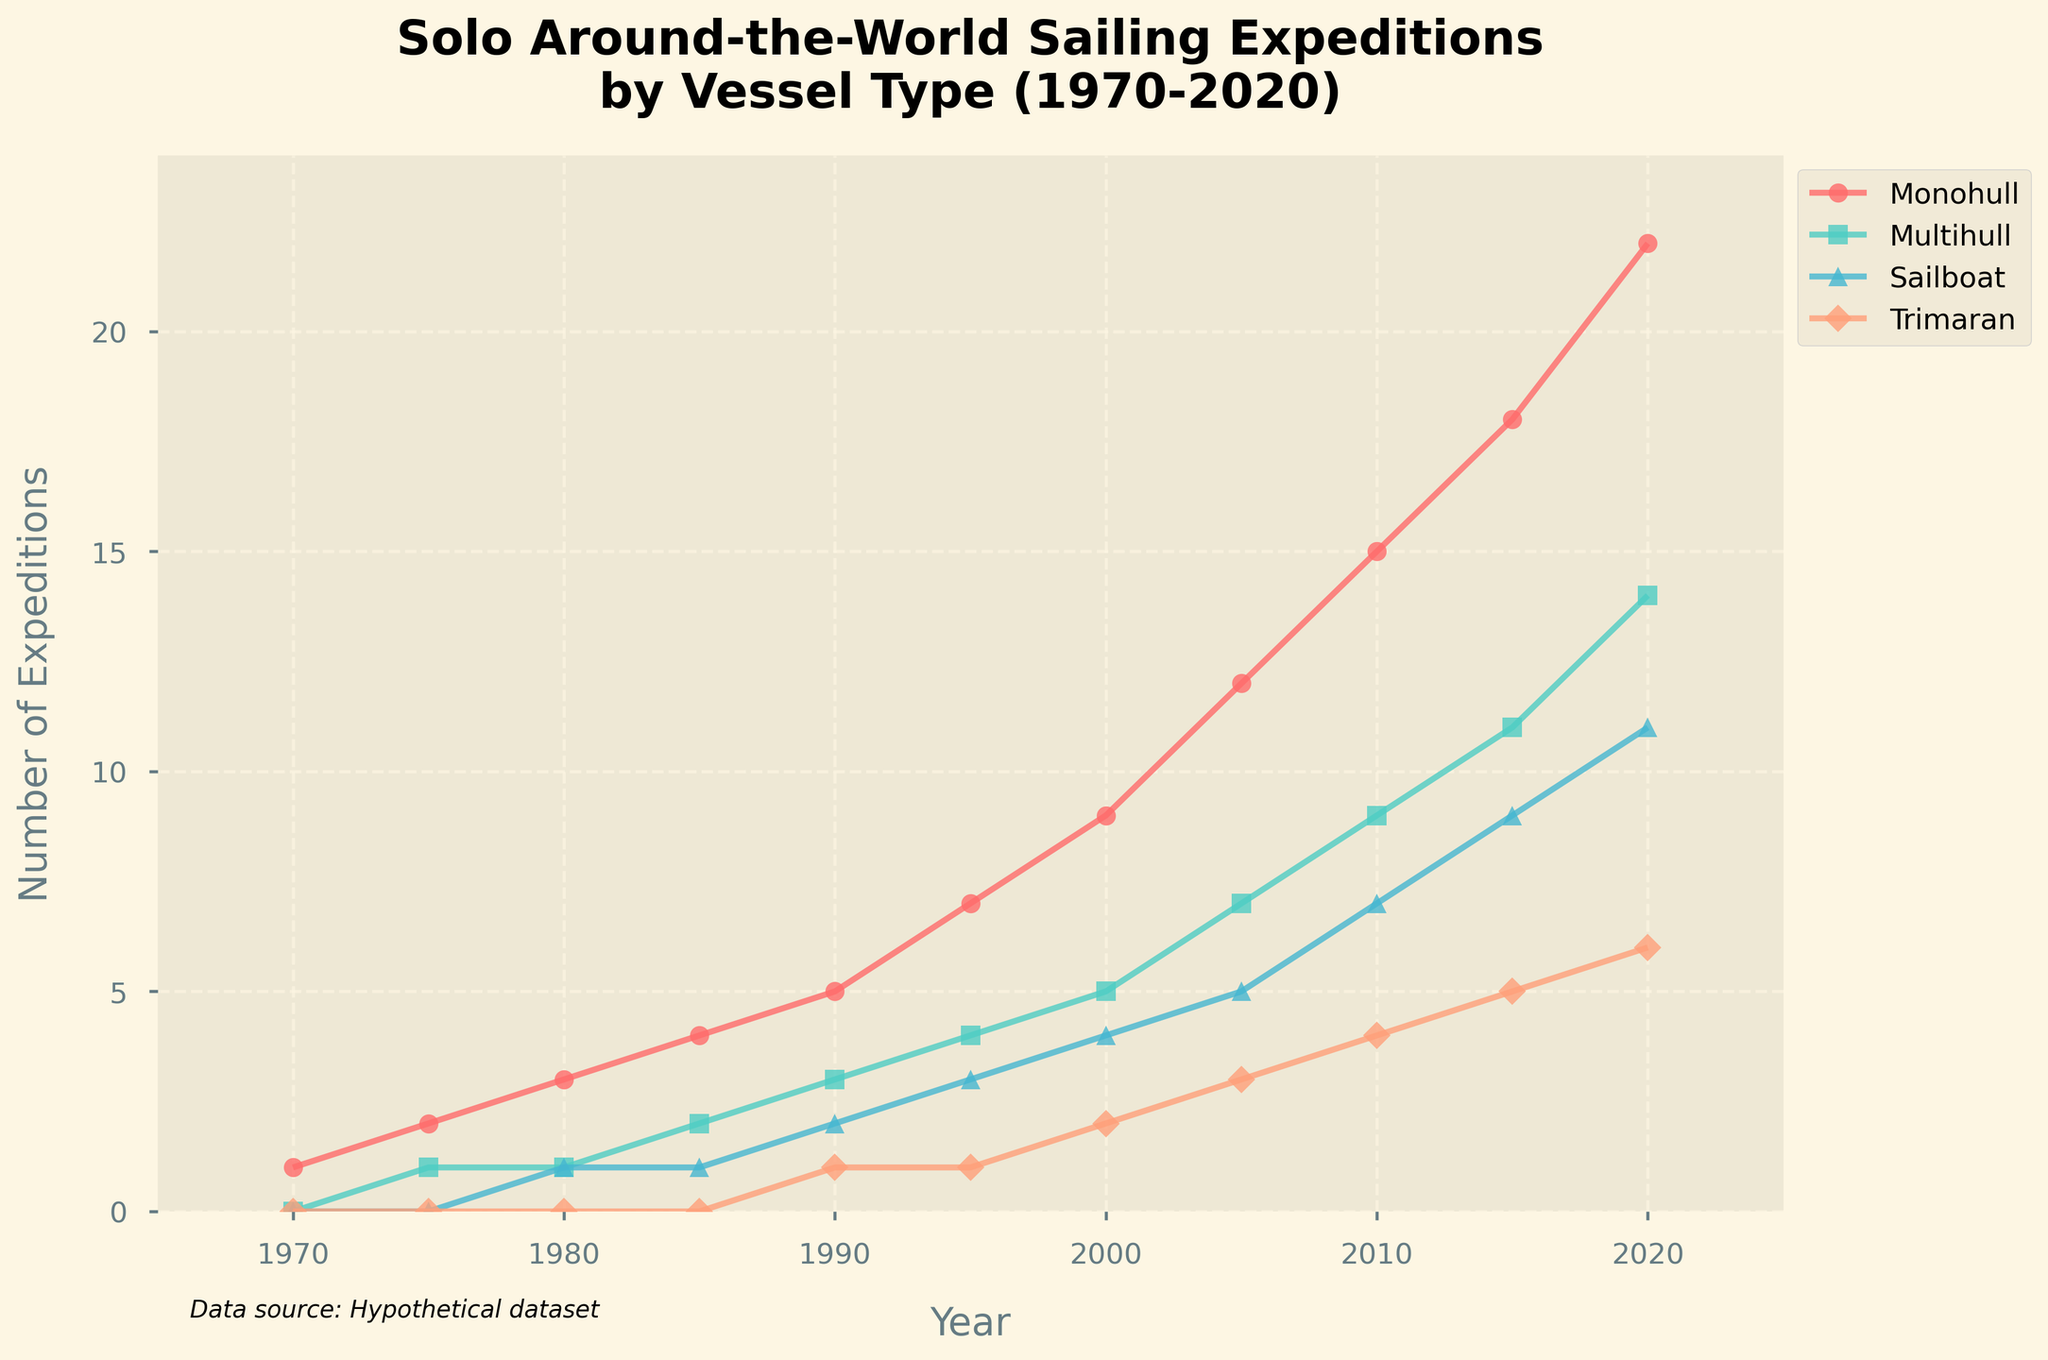What's the general trend in the number of solo around-the-world sailing expeditions for Monohulls from 1970 to 2020? The number of Monohull expeditions increases consistently over time. In 1970 there was 1, while by 2020 it grew to 22, indicating a clear upward trend.
Answer: Increasing trend What was the total number of Multihull expeditions completed by 2000? Add the number of Multihull expeditions from 1970, 1975, 1980, 1985, 1990, 1995, and 2000. 0 + 1 + 1 + 2 + 3 + 4 + 5 = 16.
Answer: 16 Which vessel type had the highest number of expeditions in 2020? In 2020, Monohull had 22 expeditions, Multihull had 14, Sailboat had 11, and Trimaran had 6. Monohull had the highest number of expeditions.
Answer: Monohull In which year did Sailboats first reach 5 expeditions? Looking at the Sailboat data, the first year it reached 5 expeditions was 2005.
Answer: 2005 How did the number of Trimaran expeditions change from 2000 to 2020? In 2000, there were 2 Trimaran expeditions, and by 2020 this had increased to 6. Thus, the number increased by 4.
Answer: Increased by 4 Between 1995 and 2005, which vessel type saw the largest increase in the number of expeditions? Calculate the difference between 2005 and 1995 for each vessel type: Monohull (12-7=5), Multihull (7-4=3), Sailboat (5-3=2), and Trimaran (3-1=2). Monohull saw the largest increase of 5.
Answer: Monohull Which category saw an expedition count exactly at 9 first, and in which year? Looking at the values, Multihull reached 9 expeditions first in 2010.
Answer: Multihull, 2010 How much more common were Monohull expeditions compared to Trimaran expeditions in 2015? In 2015, Monohull had 18 expeditions, and Trimaran had 5. The difference is 18 - 5 = 13.
Answer: 13 What's the combined total for all vessel types in 1985? Add the numbers for Monohull, Multihull, Sailboat, and Trimaran in 1985: 4 + 2 + 1 + 0 = 7.
Answer: 7 What was the percentage increase in Monohull expeditions from 2000 to 2020? Calculate the percentage increase: ((22 - 9) / 9) * 100 = 144.44%.
Answer: 144.44% 